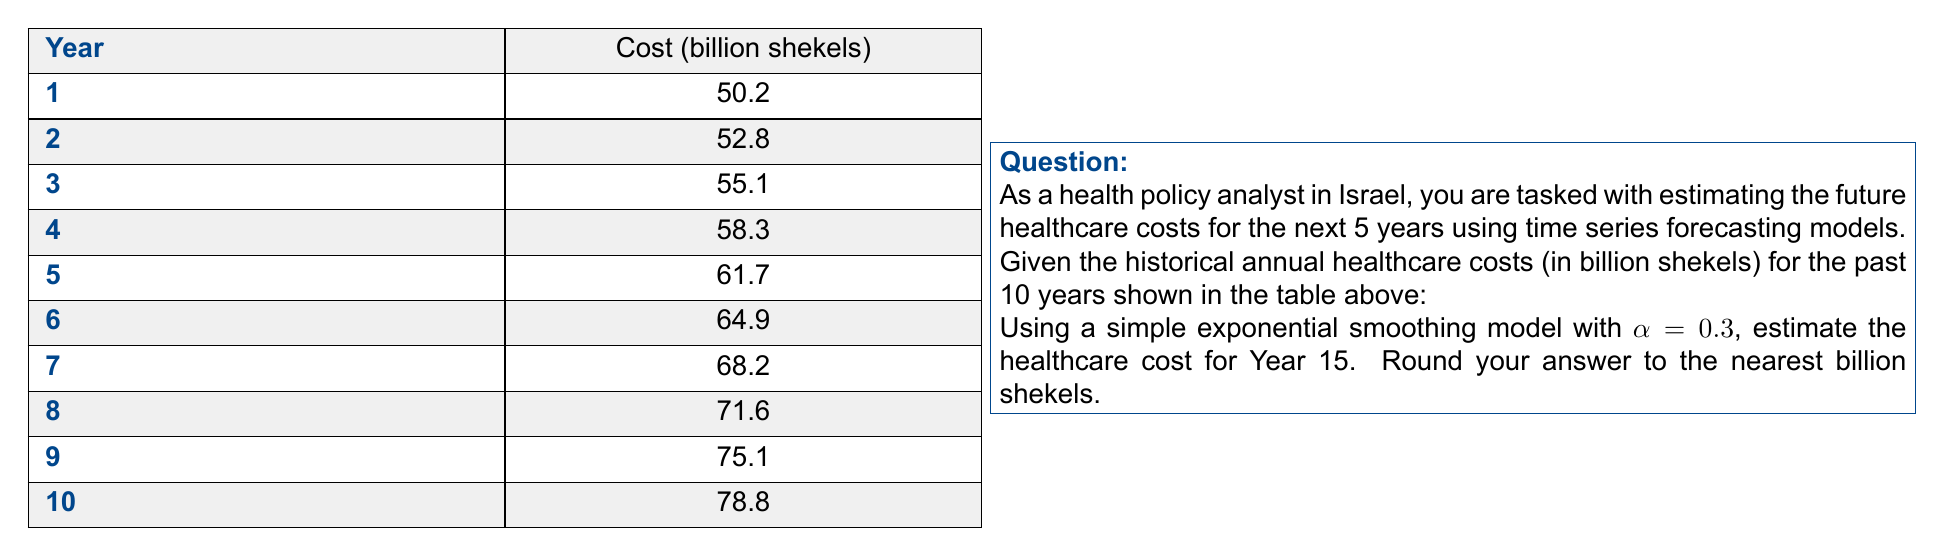Teach me how to tackle this problem. To solve this problem, we'll use the simple exponential smoothing model, which is given by the formula:

$$F_{t+1} = \alpha Y_t + (1-\alpha)F_t$$

Where:
$F_{t+1}$ is the forecast for the next period
$\alpha$ is the smoothing factor (0.3 in this case)
$Y_t$ is the actual value at time t
$F_t$ is the forecast for the current period

Let's follow these steps:

1. Initialize the forecast:
   We'll use the first actual value as our initial forecast.
   $F_1 = 50.2$

2. Calculate forecasts for years 2-10:
   For t = 1 to 9:
   $F_{t+1} = 0.3Y_t + 0.7F_t$

3. Use the model to forecast years 11-15:
   For t = 10 to 14:
   $F_{t+1} = F_t$ (since we don't have actual values)

Let's perform the calculations:

Year 2: $F_2 = 0.3(50.2) + 0.7(50.2) = 50.2$
Year 3: $F_3 = 0.3(52.8) + 0.7(50.2) = 50.98$
Year 4: $F_4 = 0.3(55.1) + 0.7(50.98) = 52.216$
Year 5: $F_5 = 0.3(58.3) + 0.7(52.216) = 54.0512$
Year 6: $F_6 = 0.3(61.7) + 0.7(54.0512) = 56.33584$
Year 7: $F_7 = 0.3(64.9) + 0.7(56.33584) = 58.935088$
Year 8: $F_8 = 0.3(68.2) + 0.7(58.935088) = 61.6545616$
Year 9: $F_9 = 0.3(71.6) + 0.7(61.6545616) = 64.5581931$
Year 10: $F_{10} = 0.3(75.1) + 0.7(64.5581931) = 67.6907352$
Year 11: $F_{11} = 67.6907352$
Year 12: $F_{12} = 67.6907352$
Year 13: $F_{13} = 67.6907352$
Year 14: $F_{14} = 67.6907352$
Year 15: $F_{15} = 67.6907352$

Rounding to the nearest billion shekels gives us 68 billion shekels.
Answer: 68 billion shekels 